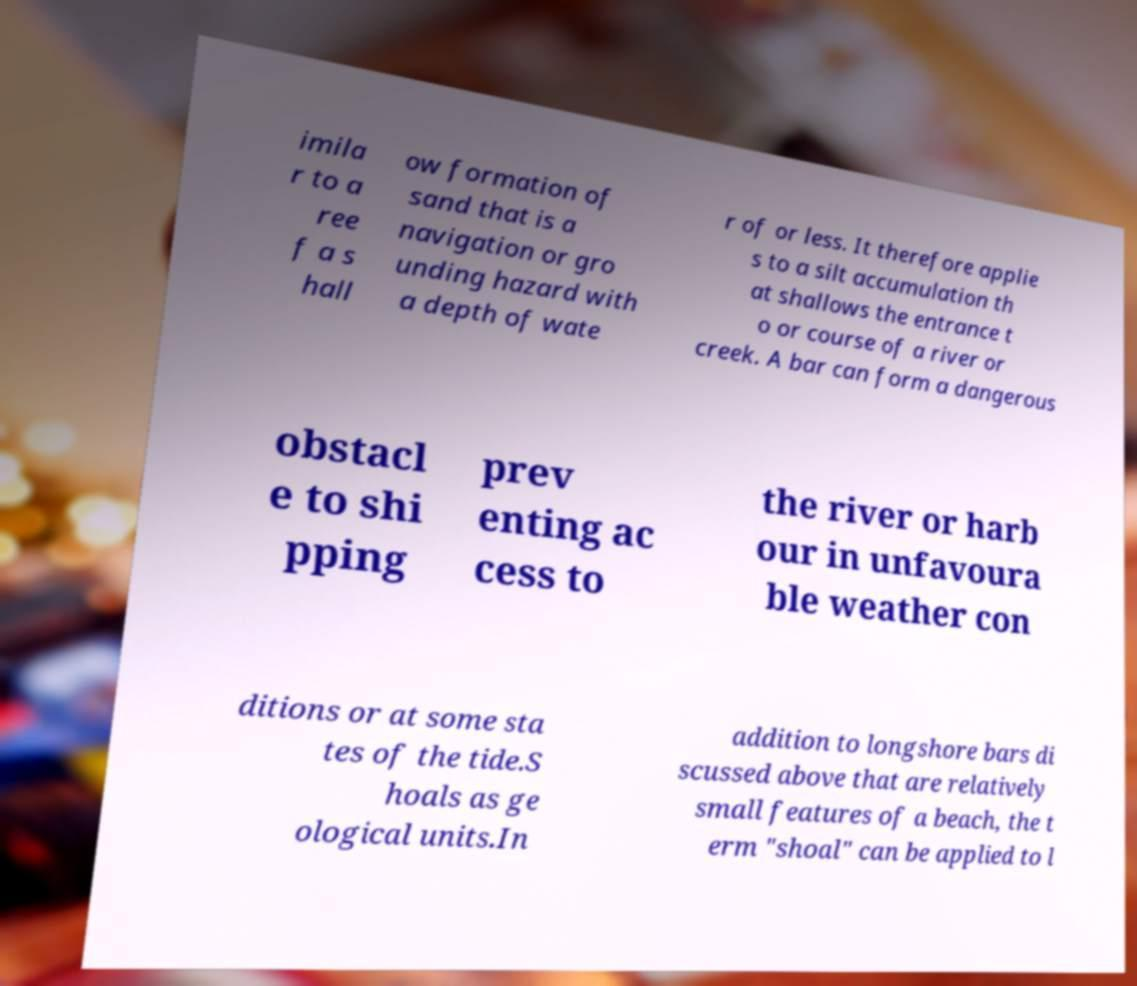For documentation purposes, I need the text within this image transcribed. Could you provide that? imila r to a ree f a s hall ow formation of sand that is a navigation or gro unding hazard with a depth of wate r of or less. It therefore applie s to a silt accumulation th at shallows the entrance t o or course of a river or creek. A bar can form a dangerous obstacl e to shi pping prev enting ac cess to the river or harb our in unfavoura ble weather con ditions or at some sta tes of the tide.S hoals as ge ological units.In addition to longshore bars di scussed above that are relatively small features of a beach, the t erm "shoal" can be applied to l 